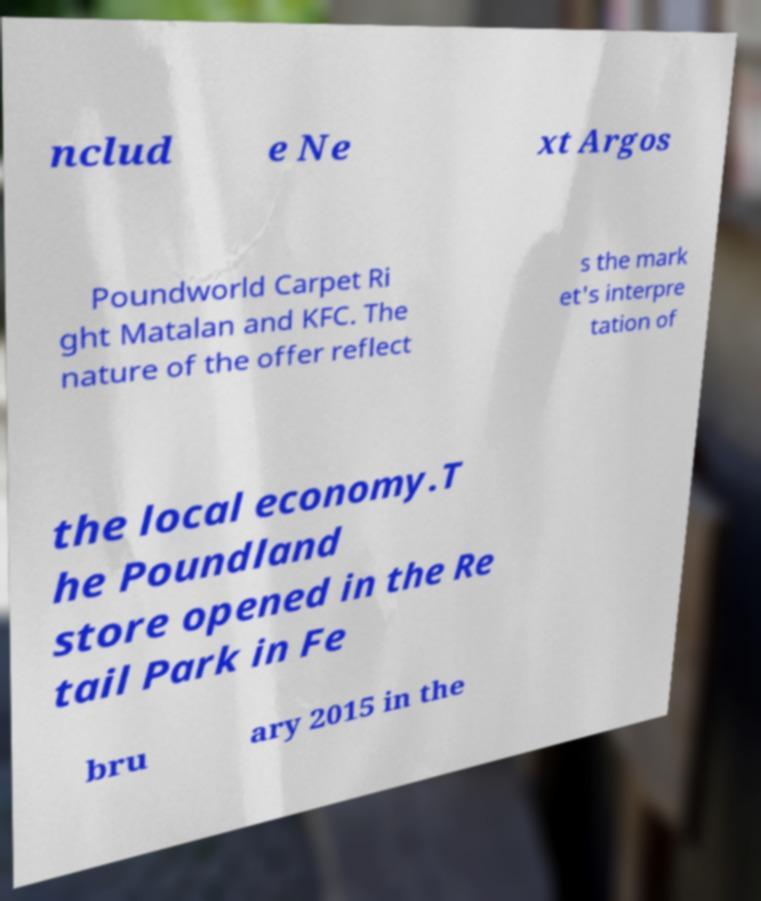For documentation purposes, I need the text within this image transcribed. Could you provide that? nclud e Ne xt Argos Poundworld Carpet Ri ght Matalan and KFC. The nature of the offer reflect s the mark et's interpre tation of the local economy.T he Poundland store opened in the Re tail Park in Fe bru ary 2015 in the 